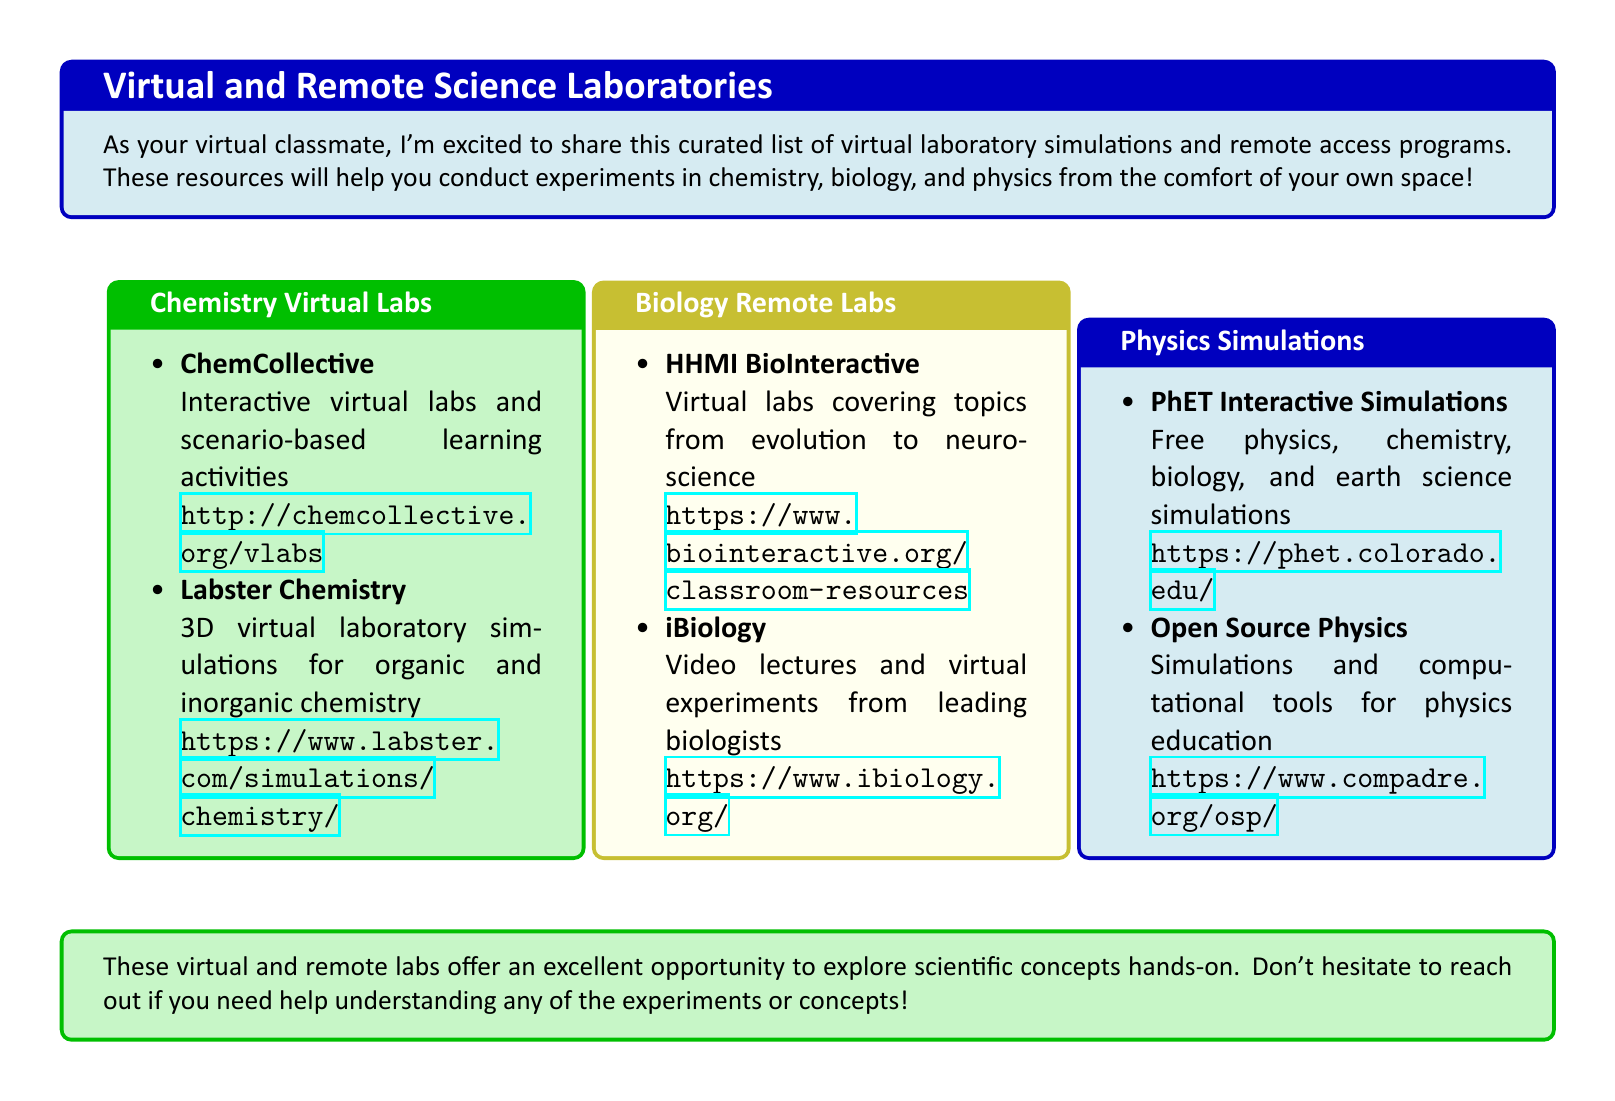What are the two main subjects covered in the virtual labs? The document categorizes virtual labs into three subjects which are chemistry, biology, and physics.
Answer: Chemistry, Biology, Physics What is the website for Labster Chemistry? The document provides a URL for Labster Chemistry, which is included within the itemization for chemistry virtual labs.
Answer: https://www.labster.com/simulations/chemistry/ Which resource covers neuroscience in virtual biology labs? The document mentions HHMI BioInteractive as a resource covering various biology topics, including neuroscience.
Answer: HHMI BioInteractive How many resources are listed under Physics Simulations? The document lists two programs under the physics simulations category.
Answer: Two What type of simulations does PhET Interactive Simulations provide? The document specifies that PhET Interactive Simulations offers simulations for physics, chemistry, biology, and earth science.
Answer: Free physics, chemistry, biology, and earth science simulations Which biology remote lab offers video lectures? The document identifies iBiology as the source that offers video lectures and virtual experiments from leading biologists.
Answer: iBiology 